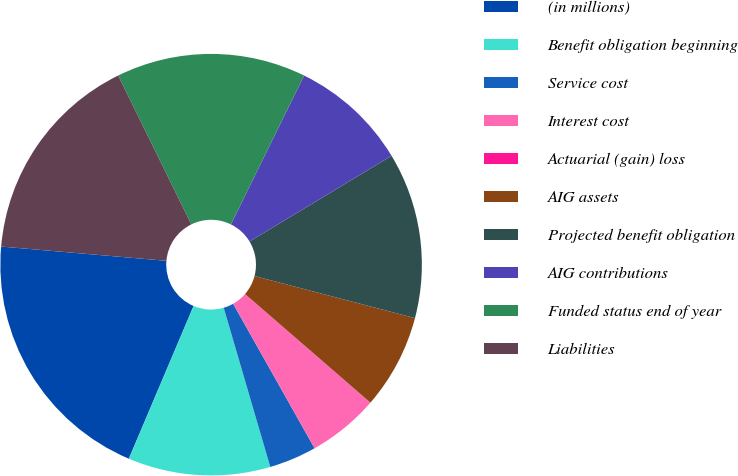<chart> <loc_0><loc_0><loc_500><loc_500><pie_chart><fcel>(in millions)<fcel>Benefit obligation beginning<fcel>Service cost<fcel>Interest cost<fcel>Actuarial (gain) loss<fcel>AIG assets<fcel>Projected benefit obligation<fcel>AIG contributions<fcel>Funded status end of year<fcel>Liabilities<nl><fcel>19.99%<fcel>10.91%<fcel>3.64%<fcel>5.46%<fcel>0.01%<fcel>7.28%<fcel>12.72%<fcel>9.09%<fcel>14.54%<fcel>16.36%<nl></chart> 